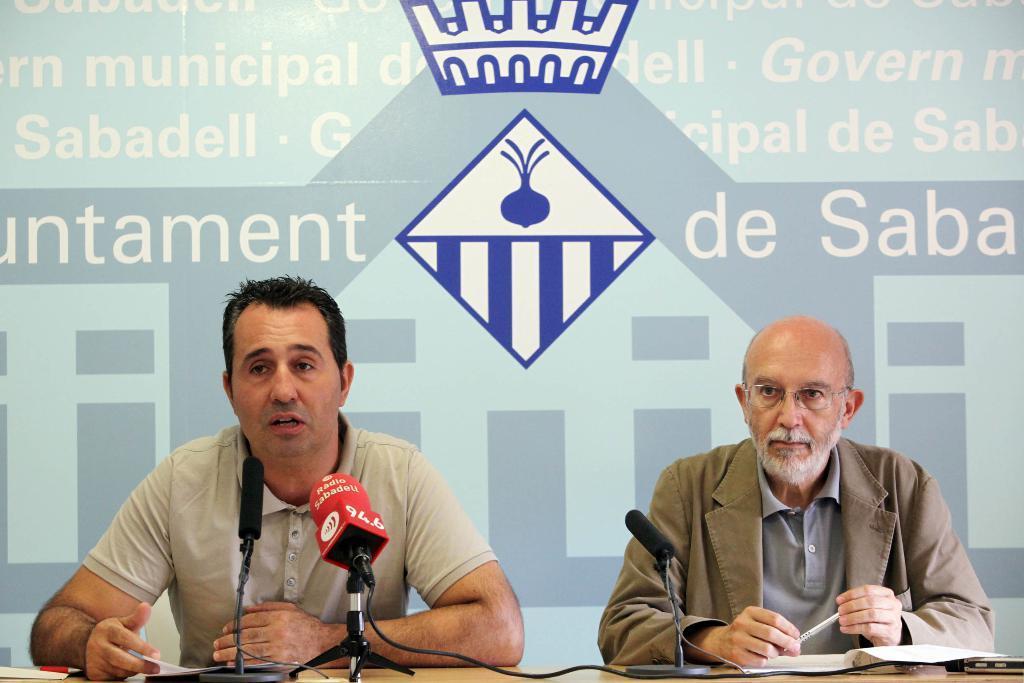How would you summarize this image in a sentence or two? In this image there are two persons. They are men. In the right side of the image a man is sitting on the chair, holding a pen in his hands. In the left side of the image a man is sitting on the chair and talking in mic. In the background there is a banner with text on it. 